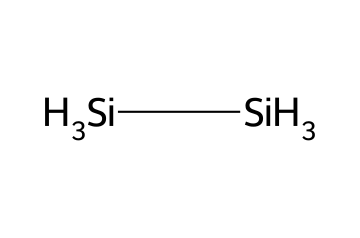How many silicon atoms are in disilane? The SMILES representation indicates two silicon atoms, as denoted by the two occurrences of "[Si]".
Answer: two What is the hybridization of the silicon atoms in disilane? In disilane, the silicon atoms are sp3 hybridized because they are tetrahedrally coordinated with hydrogen atoms, forming four sigma bonds in total.
Answer: sp3 What is the molecular geometry of disilane? Disilane has a molecular geometry that is tetrahedral around each silicon atom, resulting in a simple chain structure.
Answer: tetrahedral What are the bond angles in disilane? The bond angles in disilane are approximately 109.5 degrees, which is characteristic of sp3 hybridization in tetrahedral geometry.
Answer: 109.5 degrees Does disilane have a linear or branched structure? Disilane has a linear structure since it consists of two silicon atoms connected by a single bond with hydrogen atoms attached.
Answer: linear How many hydrogen atoms are present in disilane? The structure shows that disilane has six hydrogen atoms, as seen in the SMILES representation with six occurrences of "[H]".
Answer: six 